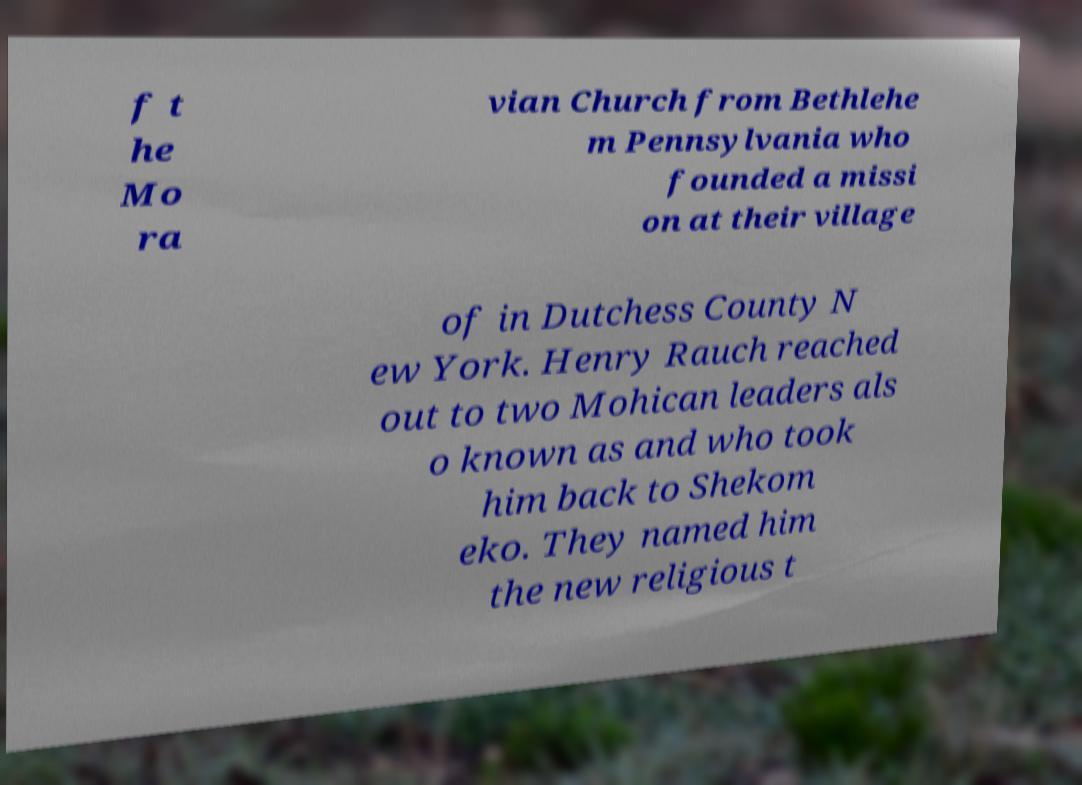I need the written content from this picture converted into text. Can you do that? f t he Mo ra vian Church from Bethlehe m Pennsylvania who founded a missi on at their village of in Dutchess County N ew York. Henry Rauch reached out to two Mohican leaders als o known as and who took him back to Shekom eko. They named him the new religious t 